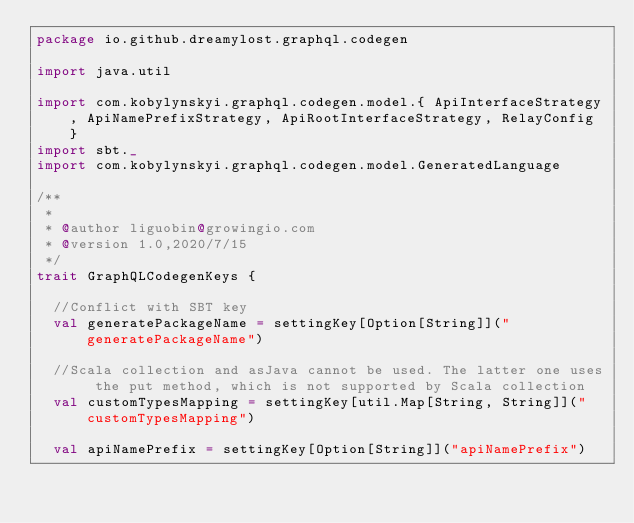<code> <loc_0><loc_0><loc_500><loc_500><_Scala_>package io.github.dreamylost.graphql.codegen

import java.util

import com.kobylynskyi.graphql.codegen.model.{ ApiInterfaceStrategy, ApiNamePrefixStrategy, ApiRootInterfaceStrategy, RelayConfig }
import sbt._
import com.kobylynskyi.graphql.codegen.model.GeneratedLanguage

/**
 *
 * @author liguobin@growingio.com
 * @version 1.0,2020/7/15
 */
trait GraphQLCodegenKeys {

  //Conflict with SBT key
  val generatePackageName = settingKey[Option[String]]("generatePackageName")

  //Scala collection and asJava cannot be used. The latter one uses the put method, which is not supported by Scala collection
  val customTypesMapping = settingKey[util.Map[String, String]]("customTypesMapping")

  val apiNamePrefix = settingKey[Option[String]]("apiNamePrefix")
</code> 